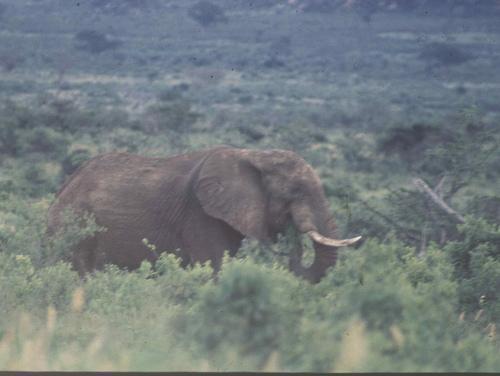How many elephants are in the picture?
Give a very brief answer. 1. 